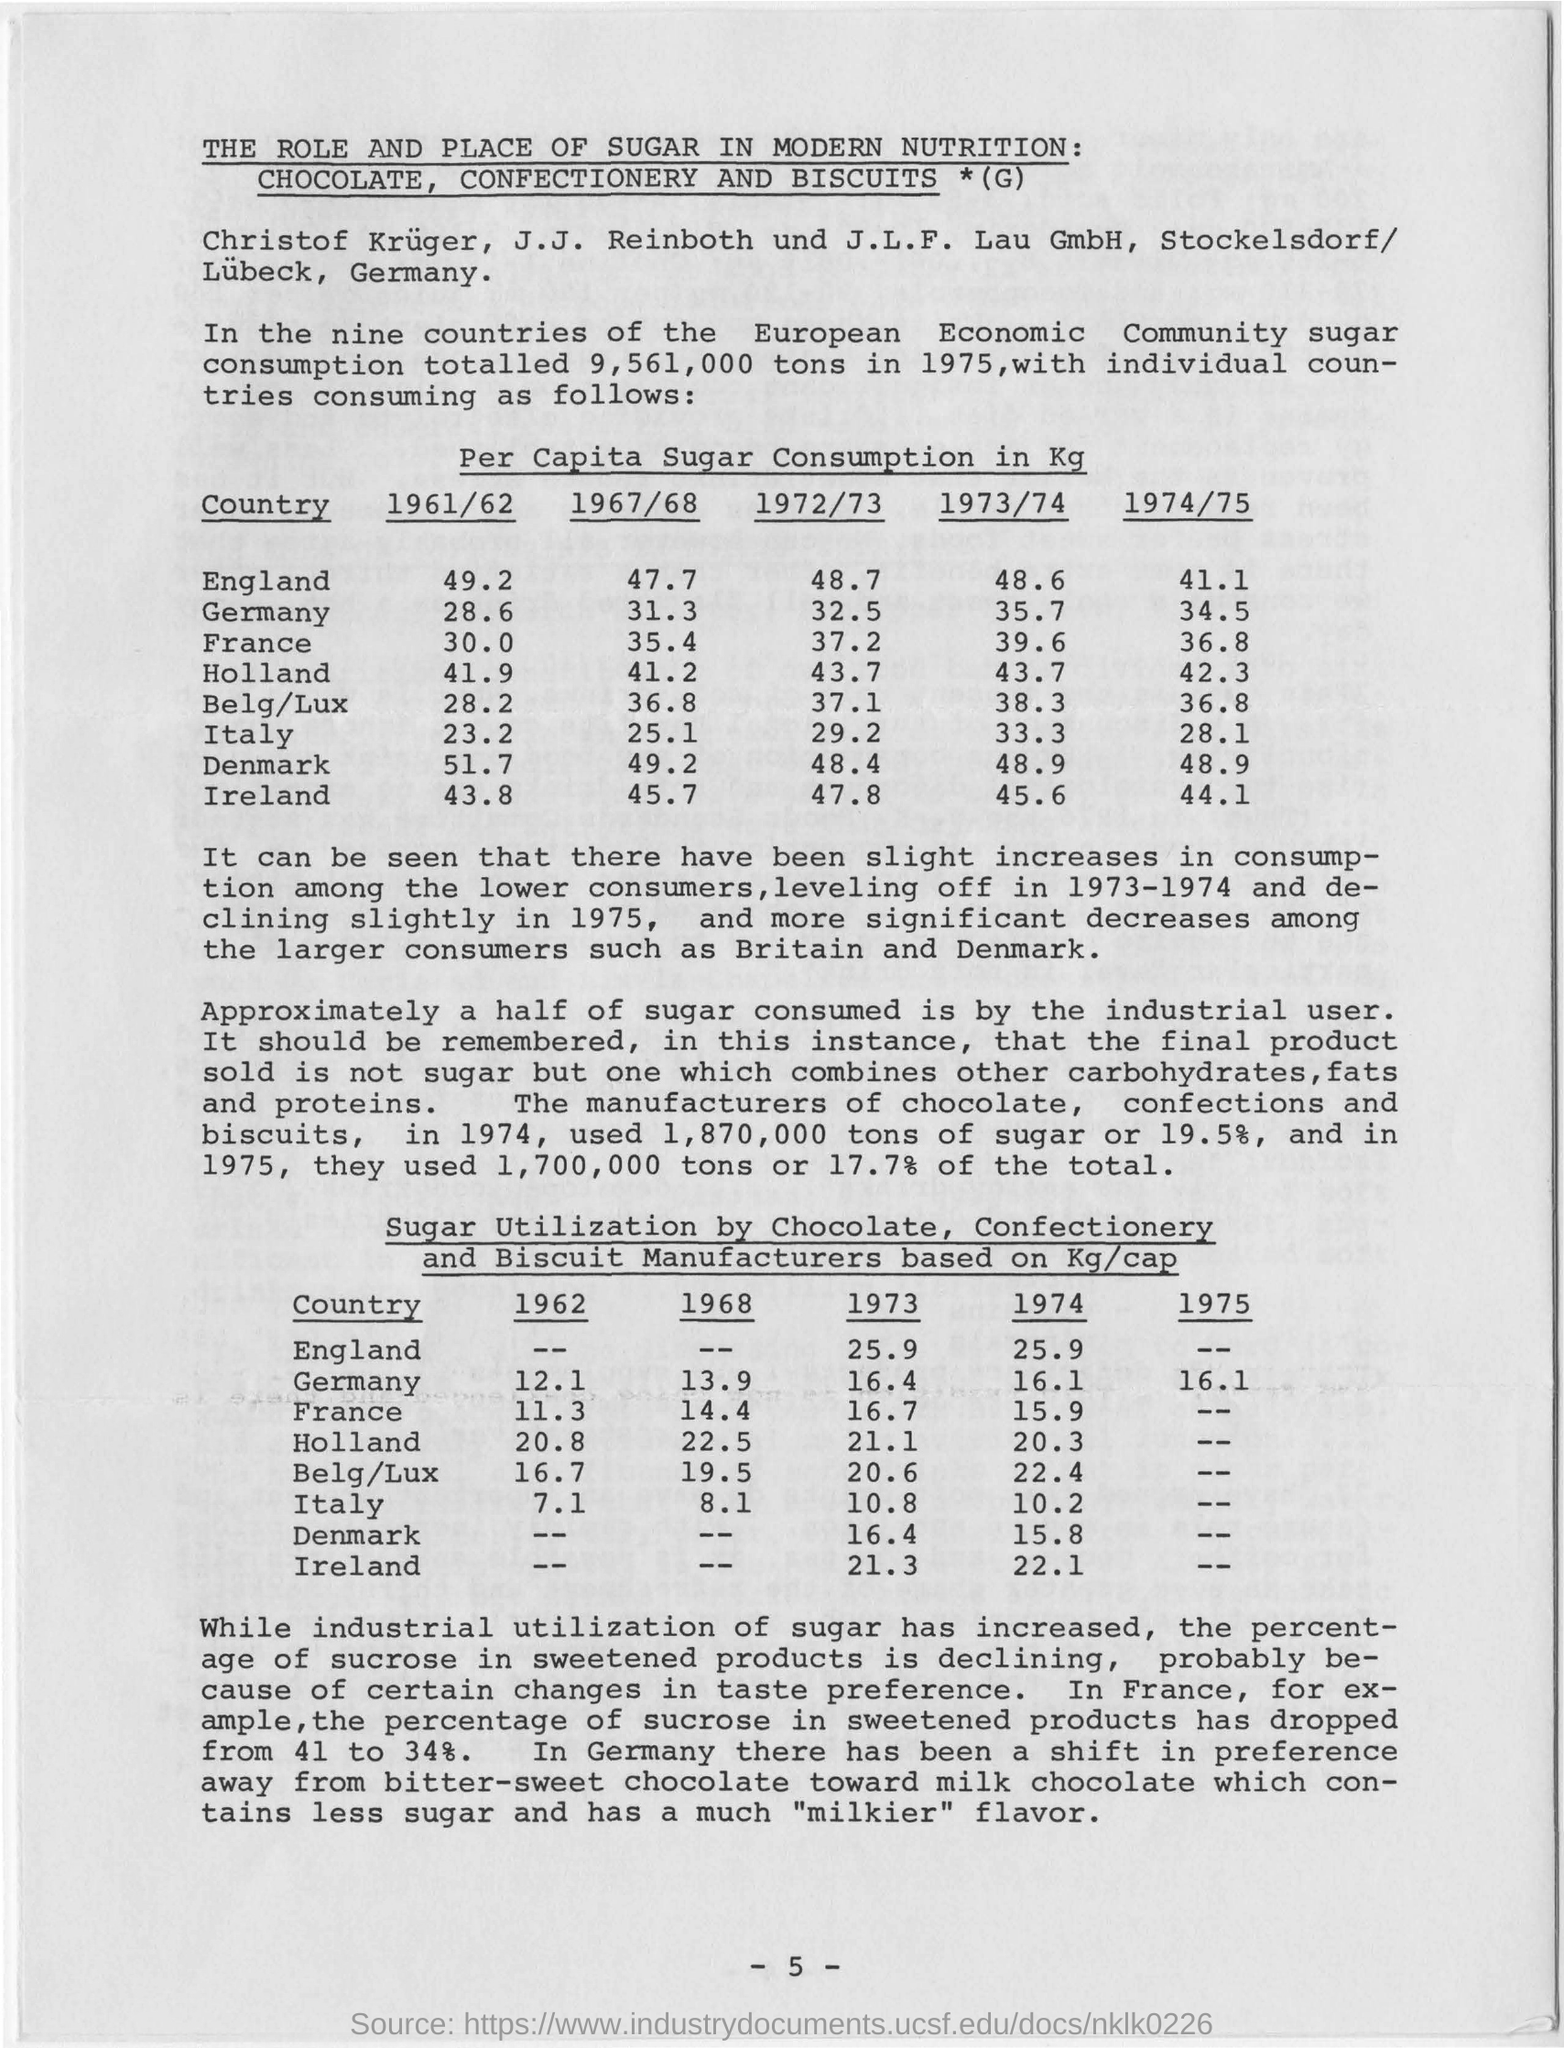What is the Per Capita Sugar Consumption in Kg for England  in the year 1961/62?
Keep it short and to the point. 49.2. Which country has the lowest Per Capita Sugar Consumption in Kg in the year 1972/73?
Offer a very short reply. ITALY. What is the value of highest Per Capita Sugar Consumption in Kg in the year 1974/75?
Your answer should be very brief. 48.9. How much is the sugar utilization (Kg/cap) for Germany in the year 1968?
Provide a succinct answer. 13.9. 